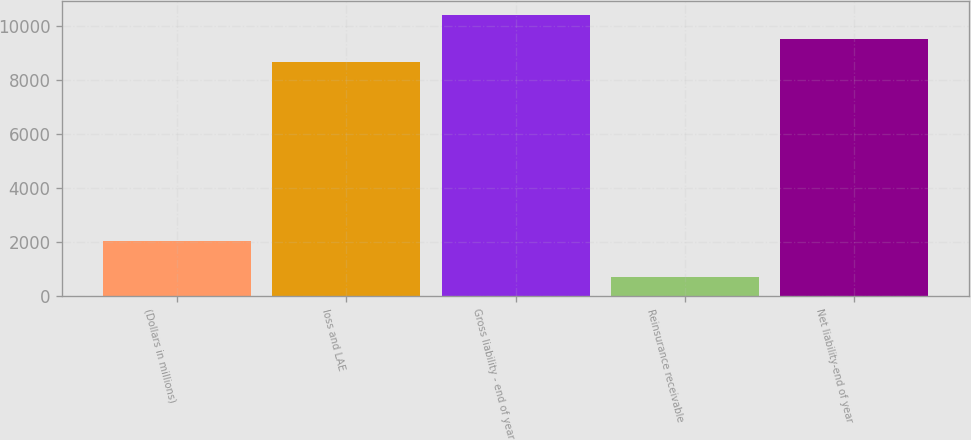<chart> <loc_0><loc_0><loc_500><loc_500><bar_chart><fcel>(Dollars in millions)<fcel>loss and LAE<fcel>Gross liability - end of year<fcel>Reinsurance receivable<fcel>Net liability-end of year<nl><fcel>2010<fcel>8650.7<fcel>10380.8<fcel>689.4<fcel>9515.77<nl></chart> 